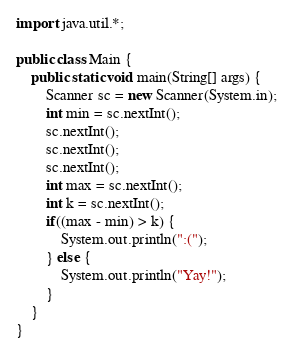Convert code to text. <code><loc_0><loc_0><loc_500><loc_500><_Java_>import java.util.*;

public class Main {
    public static void main(String[] args) {
        Scanner sc = new Scanner(System.in);
        int min = sc.nextInt();
        sc.nextInt();
        sc.nextInt();
        sc.nextInt();
        int max = sc.nextInt();
        int k = sc.nextInt();
        if((max - min) > k) {
            System.out.println(":(");
        } else {
            System.out.println("Yay!");
        }
    }
}</code> 